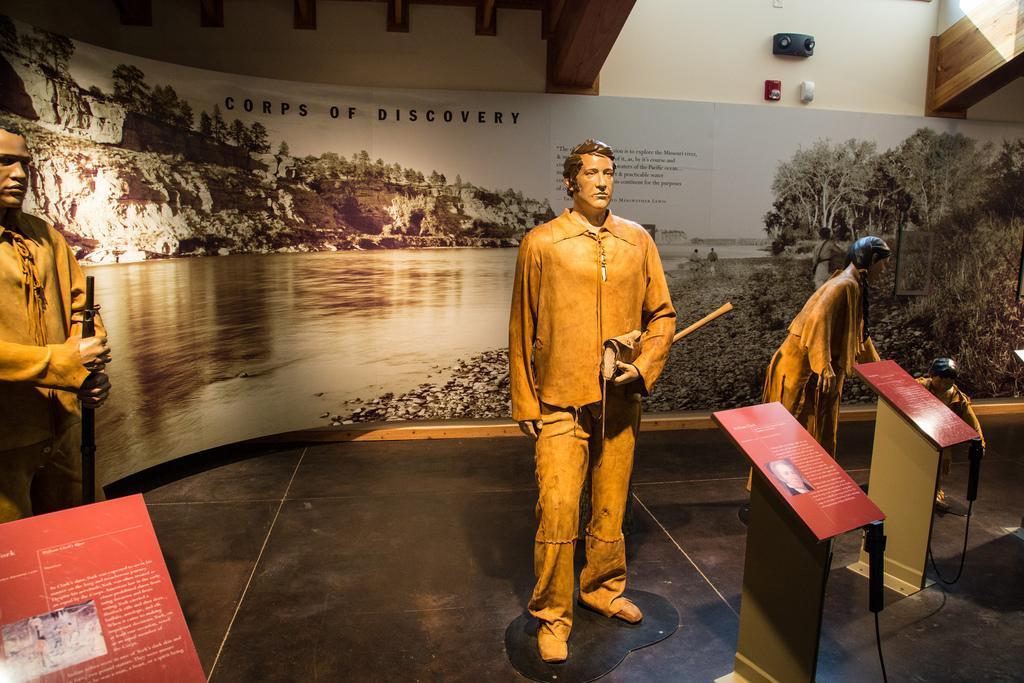How would you summarize this image in a sentence or two? In the picture I can see three sculptures on the floor. Here we can see boards on which we can see some text and images of people. In the background, we can see the board on which we can see the water, trees and hills and we can see some edited text. 